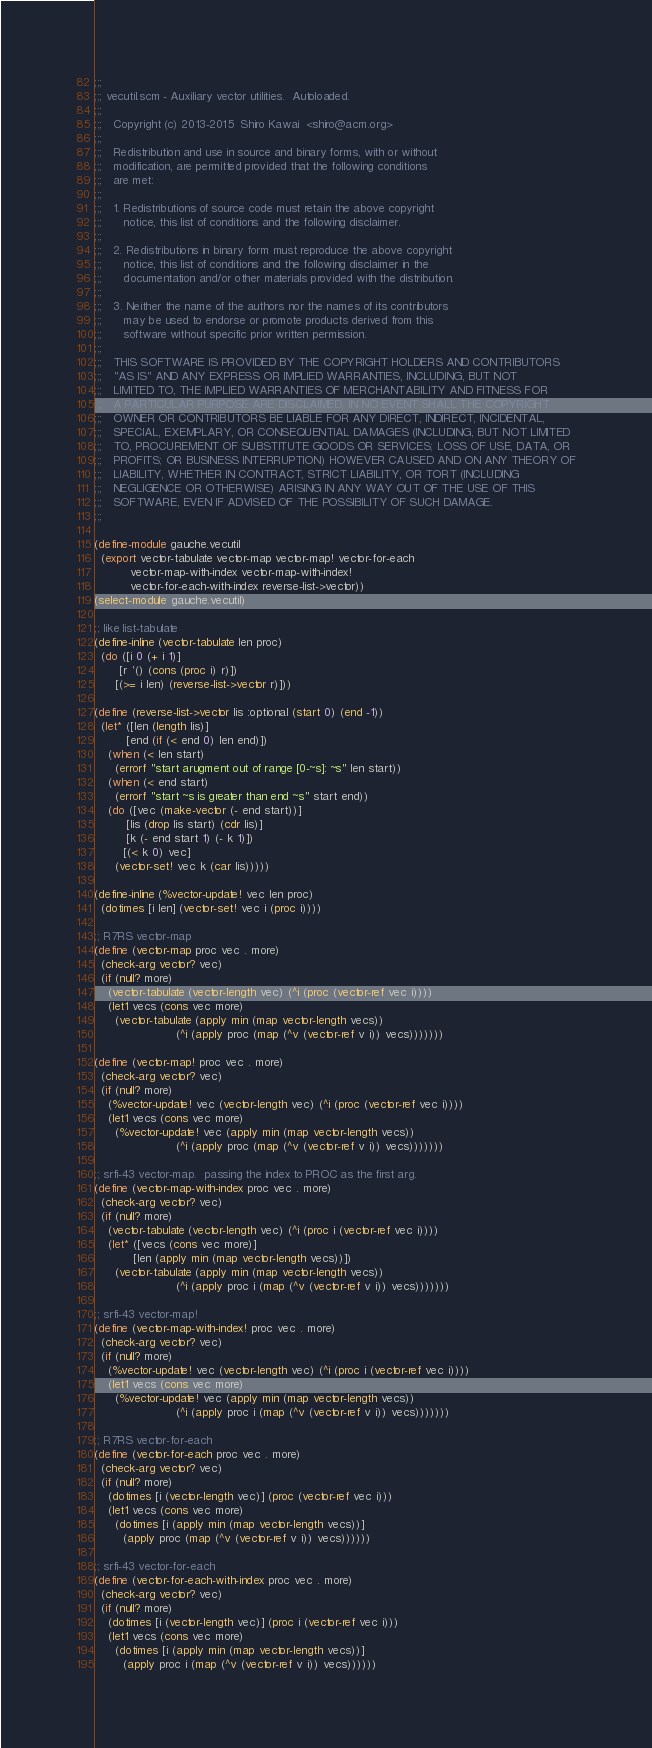<code> <loc_0><loc_0><loc_500><loc_500><_Scheme_>;;;
;;; vecutil.scm - Auxiliary vector utilities.  Autoloaded.
;;;
;;;   Copyright (c) 2013-2015  Shiro Kawai  <shiro@acm.org>
;;;
;;;   Redistribution and use in source and binary forms, with or without
;;;   modification, are permitted provided that the following conditions
;;;   are met:
;;;
;;;   1. Redistributions of source code must retain the above copyright
;;;      notice, this list of conditions and the following disclaimer.
;;;
;;;   2. Redistributions in binary form must reproduce the above copyright
;;;      notice, this list of conditions and the following disclaimer in the
;;;      documentation and/or other materials provided with the distribution.
;;;
;;;   3. Neither the name of the authors nor the names of its contributors
;;;      may be used to endorse or promote products derived from this
;;;      software without specific prior written permission.
;;;
;;;   THIS SOFTWARE IS PROVIDED BY THE COPYRIGHT HOLDERS AND CONTRIBUTORS
;;;   "AS IS" AND ANY EXPRESS OR IMPLIED WARRANTIES, INCLUDING, BUT NOT
;;;   LIMITED TO, THE IMPLIED WARRANTIES OF MERCHANTABILITY AND FITNESS FOR
;;;   A PARTICULAR PURPOSE ARE DISCLAIMED. IN NO EVENT SHALL THE COPYRIGHT
;;;   OWNER OR CONTRIBUTORS BE LIABLE FOR ANY DIRECT, INDIRECT, INCIDENTAL,
;;;   SPECIAL, EXEMPLARY, OR CONSEQUENTIAL DAMAGES (INCLUDING, BUT NOT LIMITED
;;;   TO, PROCUREMENT OF SUBSTITUTE GOODS OR SERVICES; LOSS OF USE, DATA, OR
;;;   PROFITS; OR BUSINESS INTERRUPTION) HOWEVER CAUSED AND ON ANY THEORY OF
;;;   LIABILITY, WHETHER IN CONTRACT, STRICT LIABILITY, OR TORT (INCLUDING
;;;   NEGLIGENCE OR OTHERWISE) ARISING IN ANY WAY OUT OF THE USE OF THIS
;;;   SOFTWARE, EVEN IF ADVISED OF THE POSSIBILITY OF SUCH DAMAGE.
;;;

(define-module gauche.vecutil
  (export vector-tabulate vector-map vector-map! vector-for-each
          vector-map-with-index vector-map-with-index!
          vector-for-each-with-index reverse-list->vector))
(select-module gauche.vecutil)

;; like list-tabulate
(define-inline (vector-tabulate len proc)
  (do ([i 0 (+ i 1)]
       [r '() (cons (proc i) r)])
      [(>= i len) (reverse-list->vector r)]))

(define (reverse-list->vector lis :optional (start 0) (end -1))
  (let* ([len (length lis)]
         [end (if (< end 0) len end)])
    (when (< len start)
      (errorf "start arugment out of range [0-~s]: ~s" len start))
    (when (< end start)
      (errorf "start ~s is greater than end ~s" start end))
    (do ([vec (make-vector (- end start))]
         [lis (drop lis start) (cdr lis)]
         [k (- end start 1) (- k 1)])
        [(< k 0) vec]
      (vector-set! vec k (car lis)))))

(define-inline (%vector-update! vec len proc)
  (dotimes [i len] (vector-set! vec i (proc i))))

;; R7RS vector-map
(define (vector-map proc vec . more)
  (check-arg vector? vec)
  (if (null? more)
    (vector-tabulate (vector-length vec) (^i (proc (vector-ref vec i))))
    (let1 vecs (cons vec more)
      (vector-tabulate (apply min (map vector-length vecs))
                       (^i (apply proc (map (^v (vector-ref v i)) vecs)))))))

(define (vector-map! proc vec . more)
  (check-arg vector? vec)
  (if (null? more)
    (%vector-update! vec (vector-length vec) (^i (proc (vector-ref vec i))))
    (let1 vecs (cons vec more)
      (%vector-update! vec (apply min (map vector-length vecs))
                       (^i (apply proc (map (^v (vector-ref v i)) vecs)))))))
  
;; srfi-43 vector-map.  passing the index to PROC as the first arg.
(define (vector-map-with-index proc vec . more)
  (check-arg vector? vec)
  (if (null? more)
    (vector-tabulate (vector-length vec) (^i (proc i (vector-ref vec i))))
    (let* ([vecs (cons vec more)]
           [len (apply min (map vector-length vecs))])
      (vector-tabulate (apply min (map vector-length vecs))
                       (^i (apply proc i (map (^v (vector-ref v i)) vecs)))))))

;; srfi-43 vector-map!
(define (vector-map-with-index! proc vec . more)
  (check-arg vector? vec)
  (if (null? more)
    (%vector-update! vec (vector-length vec) (^i (proc i (vector-ref vec i))))
    (let1 vecs (cons vec more)
      (%vector-update! vec (apply min (map vector-length vecs))
                       (^i (apply proc i (map (^v (vector-ref v i)) vecs)))))))

;; R7RS vector-for-each
(define (vector-for-each proc vec . more)
  (check-arg vector? vec)
  (if (null? more)
    (dotimes [i (vector-length vec)] (proc (vector-ref vec i)))
    (let1 vecs (cons vec more)
      (dotimes [i (apply min (map vector-length vecs))]
        (apply proc (map (^v (vector-ref v i)) vecs))))))

;; srfi-43 vector-for-each
(define (vector-for-each-with-index proc vec . more)
  (check-arg vector? vec)
  (if (null? more)
    (dotimes [i (vector-length vec)] (proc i (vector-ref vec i)))
    (let1 vecs (cons vec more)
      (dotimes [i (apply min (map vector-length vecs))]
        (apply proc i (map (^v (vector-ref v i)) vecs))))))
</code> 